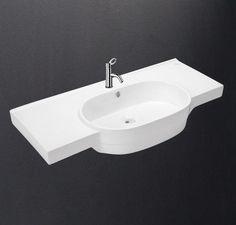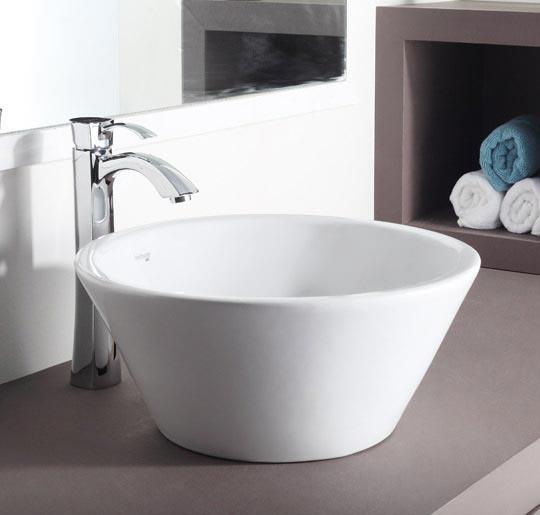The first image is the image on the left, the second image is the image on the right. Given the left and right images, does the statement "In one of the images, there is a freestanding white sink with a shelf underneath and chrome legs." hold true? Answer yes or no. No. The first image is the image on the left, the second image is the image on the right. Given the left and right images, does the statement "There is a shelf under the sink in one of the images." hold true? Answer yes or no. No. 